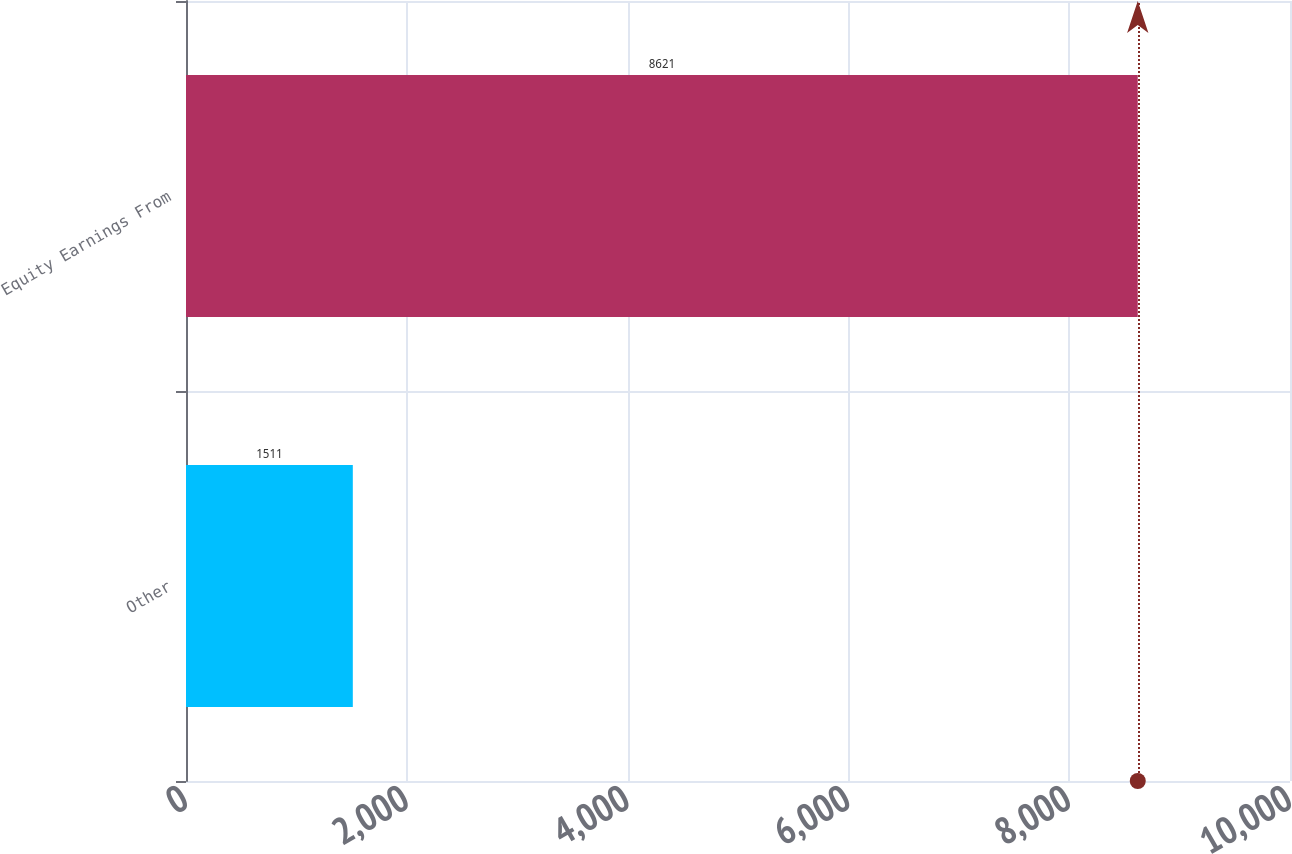Convert chart. <chart><loc_0><loc_0><loc_500><loc_500><bar_chart><fcel>Other<fcel>Equity Earnings From<nl><fcel>1511<fcel>8621<nl></chart> 